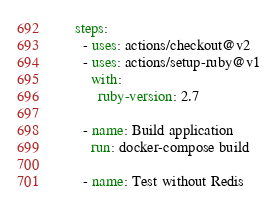Convert code to text. <code><loc_0><loc_0><loc_500><loc_500><_YAML_>
    steps:
      - uses: actions/checkout@v2
      - uses: actions/setup-ruby@v1
        with:
          ruby-version: 2.7

      - name: Build application
        run: docker-compose build

      - name: Test without Redis</code> 